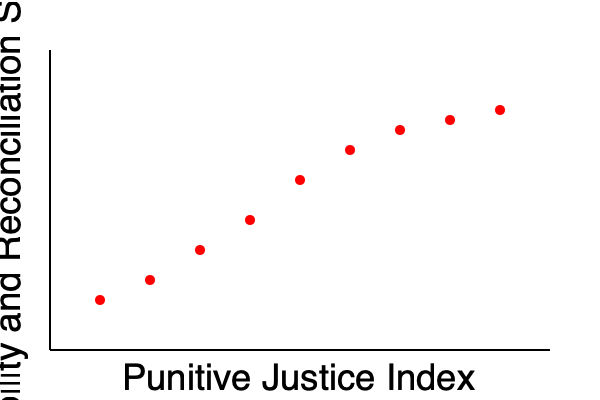Based on the scatter plot of international case studies on punitive vs. restorative justice outcomes, what is the relationship between the Punitive Justice Index and the Stability and Reconciliation Score? How does this data support or challenge the effectiveness of a more punitive approach to post-conflict justice? To analyze the relationship between the Punitive Justice Index and the Stability and Reconciliation Score, we need to follow these steps:

1. Observe the overall trend: The scatter plot shows a clear downward trend from left to right.

2. Interpret the axes:
   - X-axis: Punitive Justice Index (increases from left to right)
   - Y-axis: Stability and Reconciliation Score (increases from bottom to top)

3. Analyze the correlation: As the Punitive Justice Index increases, the Stability and Reconciliation Score decreases, indicating a negative correlation.

4. Quantify the relationship: The relationship appears to be non-linear, with a steeper decline in Stability and Reconciliation Scores at lower levels of the Punitive Justice Index, and a more gradual decline at higher levels.

5. Consider the implications:
   a) Higher punitive justice measures are associated with lower stability and reconciliation outcomes.
   b) This challenges the effectiveness of a more punitive approach to post-conflict justice.
   c) The data suggests that as societies implement more punitive measures, they may experience diminishing returns in terms of stability and reconciliation.

6. Limitations:
   - Correlation does not imply causation; other factors may influence these outcomes.
   - The scatter plot doesn't provide information on specific cases or contexts.

7. Policy implications:
   - Policymakers advocating for punitive justice may need to reconsider their approach.
   - A balance between punitive and restorative justice might be more effective in achieving stability and reconciliation.
Answer: Negative correlation; challenges punitive approach effectiveness 